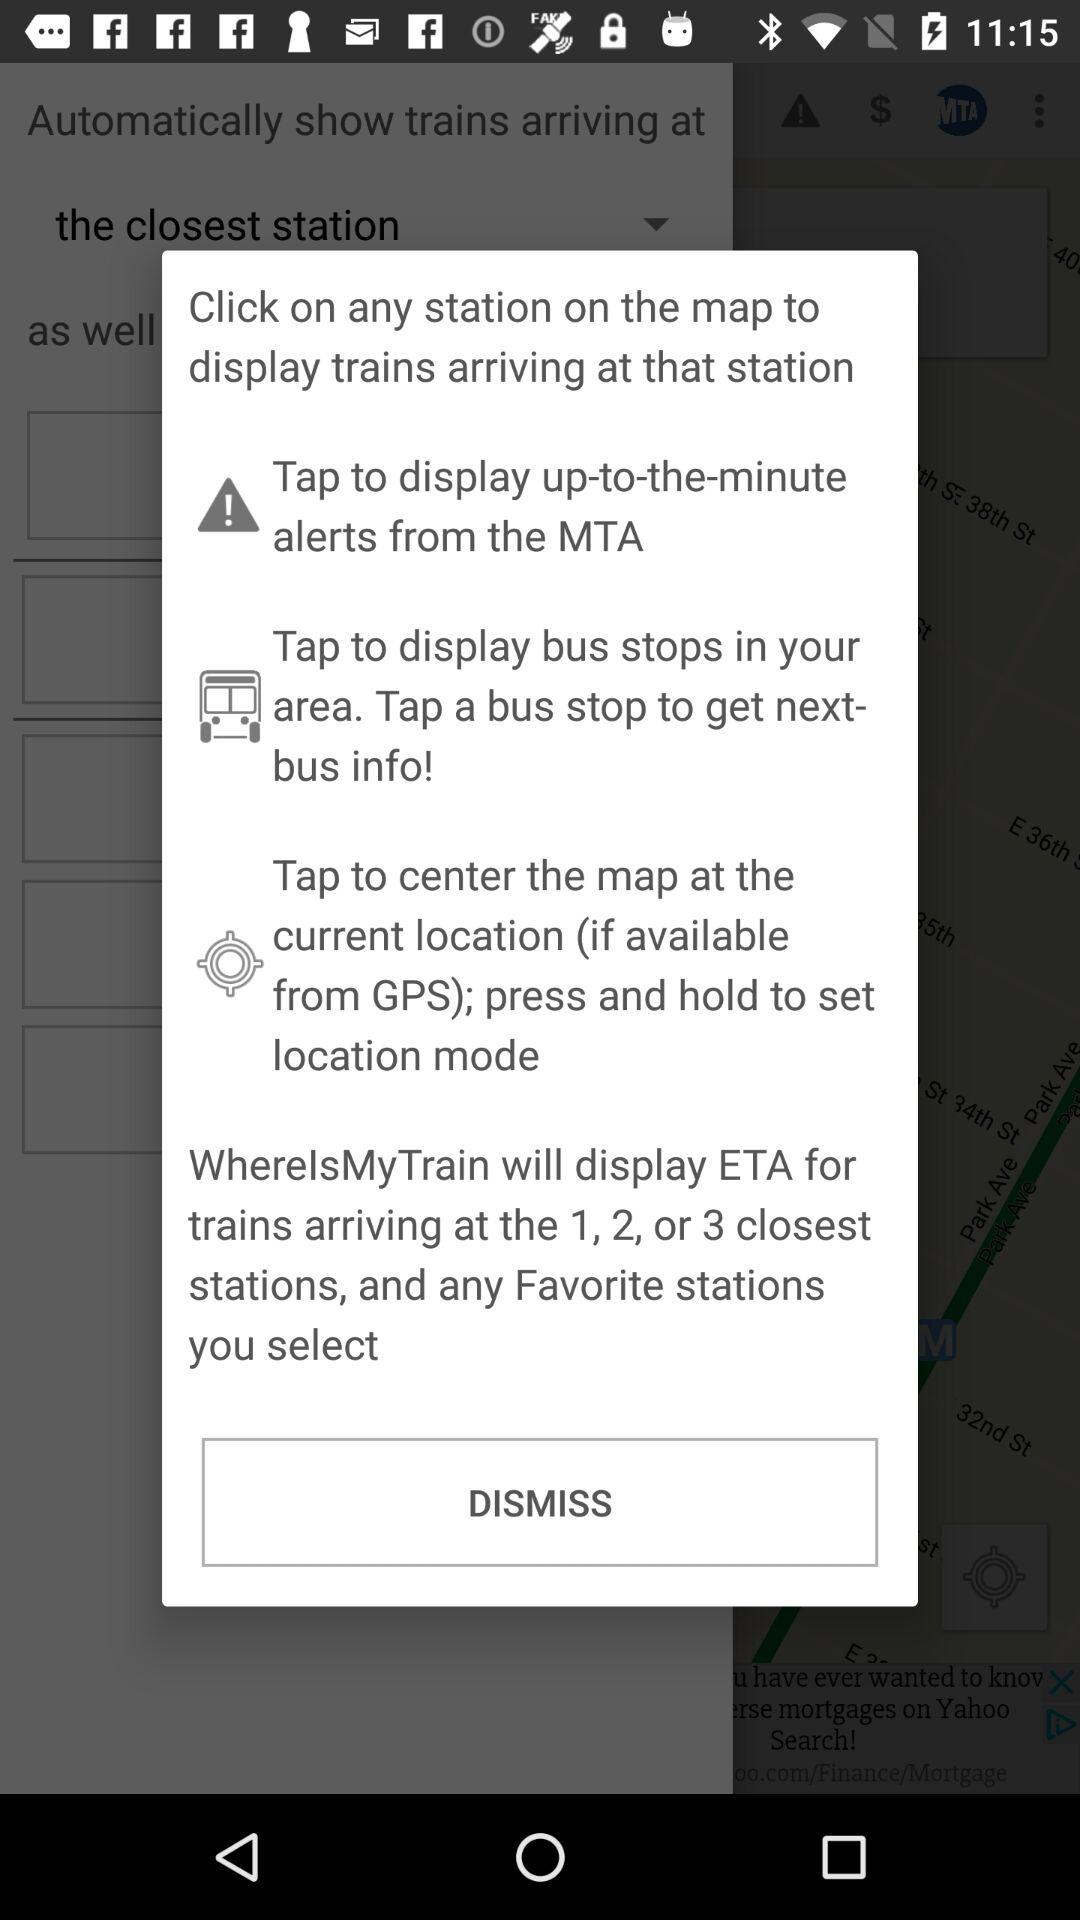What will the "WhereIsMyTrain" application display? The "WhereIsMyTrain" application will display ETA for trains arriving at the 1, 2, or 3 closest stations and any favourite stations you select. 